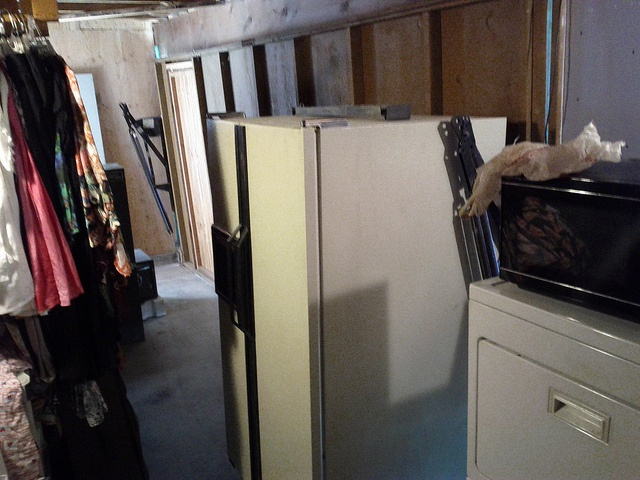Describe the objects in this image and their specific colors. I can see refrigerator in black, darkgray, gray, and beige tones and microwave in black and gray tones in this image. 